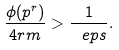Convert formula to latex. <formula><loc_0><loc_0><loc_500><loc_500>\frac { \phi ( p ^ { r } ) } { 4 r m } > \frac { 1 } { \ e p s } .</formula> 